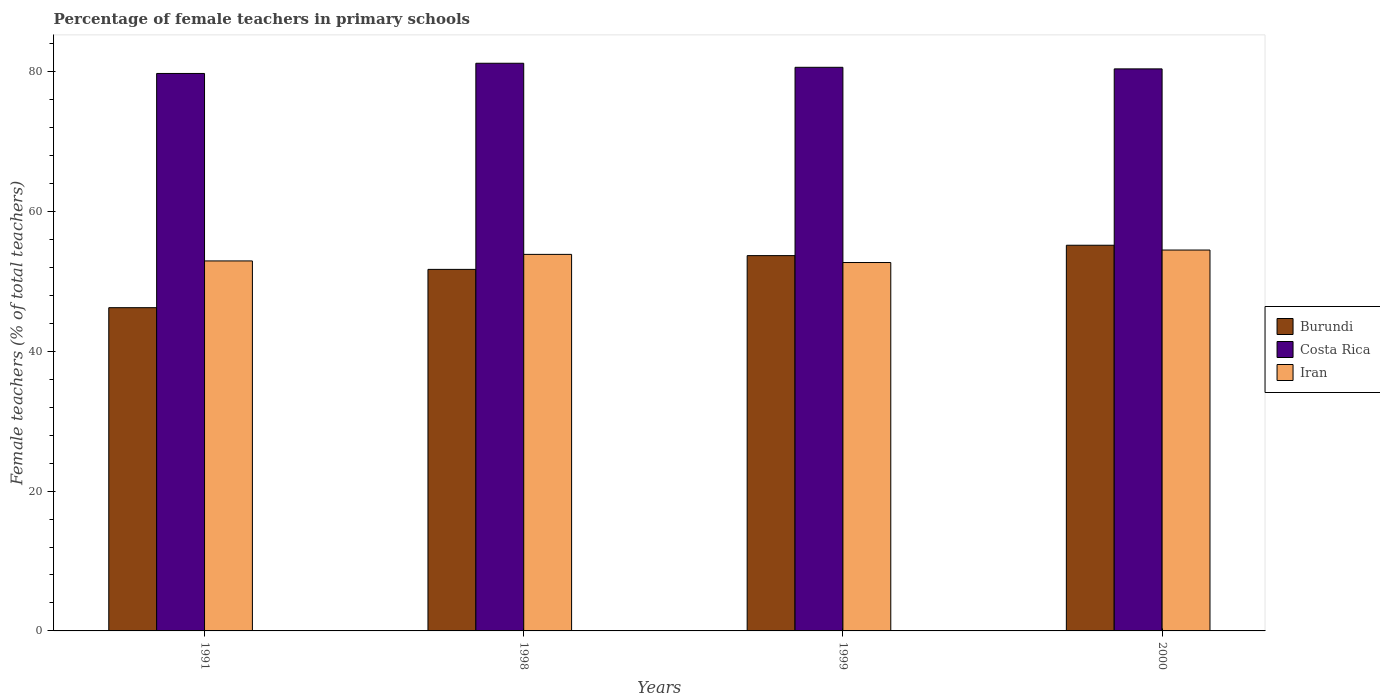How many groups of bars are there?
Provide a short and direct response. 4. Are the number of bars on each tick of the X-axis equal?
Offer a terse response. Yes. How many bars are there on the 3rd tick from the right?
Offer a terse response. 3. What is the label of the 1st group of bars from the left?
Ensure brevity in your answer.  1991. In how many cases, is the number of bars for a given year not equal to the number of legend labels?
Offer a very short reply. 0. What is the percentage of female teachers in Costa Rica in 1998?
Make the answer very short. 81.19. Across all years, what is the maximum percentage of female teachers in Burundi?
Provide a short and direct response. 55.16. Across all years, what is the minimum percentage of female teachers in Burundi?
Give a very brief answer. 46.23. What is the total percentage of female teachers in Burundi in the graph?
Keep it short and to the point. 206.79. What is the difference between the percentage of female teachers in Costa Rica in 1998 and that in 2000?
Keep it short and to the point. 0.8. What is the difference between the percentage of female teachers in Costa Rica in 2000 and the percentage of female teachers in Iran in 1991?
Your answer should be very brief. 27.47. What is the average percentage of female teachers in Iran per year?
Keep it short and to the point. 53.49. In the year 1991, what is the difference between the percentage of female teachers in Iran and percentage of female teachers in Costa Rica?
Make the answer very short. -26.81. In how many years, is the percentage of female teachers in Burundi greater than 60 %?
Ensure brevity in your answer.  0. What is the ratio of the percentage of female teachers in Iran in 1991 to that in 1999?
Make the answer very short. 1. What is the difference between the highest and the second highest percentage of female teachers in Burundi?
Make the answer very short. 1.48. What is the difference between the highest and the lowest percentage of female teachers in Iran?
Give a very brief answer. 1.78. In how many years, is the percentage of female teachers in Iran greater than the average percentage of female teachers in Iran taken over all years?
Provide a succinct answer. 2. What does the 3rd bar from the left in 1999 represents?
Your response must be concise. Iran. What does the 3rd bar from the right in 2000 represents?
Offer a terse response. Burundi. Is it the case that in every year, the sum of the percentage of female teachers in Burundi and percentage of female teachers in Costa Rica is greater than the percentage of female teachers in Iran?
Provide a short and direct response. Yes. Are all the bars in the graph horizontal?
Ensure brevity in your answer.  No. What is the difference between two consecutive major ticks on the Y-axis?
Ensure brevity in your answer.  20. How many legend labels are there?
Make the answer very short. 3. What is the title of the graph?
Your answer should be very brief. Percentage of female teachers in primary schools. Does "Ethiopia" appear as one of the legend labels in the graph?
Offer a very short reply. No. What is the label or title of the Y-axis?
Your answer should be compact. Female teachers (% of total teachers). What is the Female teachers (% of total teachers) of Burundi in 1991?
Your response must be concise. 46.23. What is the Female teachers (% of total teachers) of Costa Rica in 1991?
Your answer should be compact. 79.73. What is the Female teachers (% of total teachers) of Iran in 1991?
Give a very brief answer. 52.92. What is the Female teachers (% of total teachers) of Burundi in 1998?
Your answer should be compact. 51.71. What is the Female teachers (% of total teachers) of Costa Rica in 1998?
Offer a terse response. 81.19. What is the Female teachers (% of total teachers) in Iran in 1998?
Your response must be concise. 53.86. What is the Female teachers (% of total teachers) in Burundi in 1999?
Ensure brevity in your answer.  53.68. What is the Female teachers (% of total teachers) in Costa Rica in 1999?
Provide a short and direct response. 80.62. What is the Female teachers (% of total teachers) of Iran in 1999?
Offer a very short reply. 52.69. What is the Female teachers (% of total teachers) in Burundi in 2000?
Ensure brevity in your answer.  55.16. What is the Female teachers (% of total teachers) in Costa Rica in 2000?
Your answer should be compact. 80.39. What is the Female teachers (% of total teachers) in Iran in 2000?
Make the answer very short. 54.48. Across all years, what is the maximum Female teachers (% of total teachers) of Burundi?
Make the answer very short. 55.16. Across all years, what is the maximum Female teachers (% of total teachers) of Costa Rica?
Provide a short and direct response. 81.19. Across all years, what is the maximum Female teachers (% of total teachers) in Iran?
Your answer should be very brief. 54.48. Across all years, what is the minimum Female teachers (% of total teachers) of Burundi?
Give a very brief answer. 46.23. Across all years, what is the minimum Female teachers (% of total teachers) of Costa Rica?
Your answer should be compact. 79.73. Across all years, what is the minimum Female teachers (% of total teachers) in Iran?
Your answer should be compact. 52.69. What is the total Female teachers (% of total teachers) in Burundi in the graph?
Keep it short and to the point. 206.79. What is the total Female teachers (% of total teachers) of Costa Rica in the graph?
Make the answer very short. 321.93. What is the total Female teachers (% of total teachers) in Iran in the graph?
Offer a very short reply. 213.95. What is the difference between the Female teachers (% of total teachers) of Burundi in 1991 and that in 1998?
Your response must be concise. -5.48. What is the difference between the Female teachers (% of total teachers) of Costa Rica in 1991 and that in 1998?
Give a very brief answer. -1.46. What is the difference between the Female teachers (% of total teachers) in Iran in 1991 and that in 1998?
Provide a succinct answer. -0.94. What is the difference between the Female teachers (% of total teachers) of Burundi in 1991 and that in 1999?
Your response must be concise. -7.45. What is the difference between the Female teachers (% of total teachers) in Costa Rica in 1991 and that in 1999?
Your answer should be very brief. -0.88. What is the difference between the Female teachers (% of total teachers) in Iran in 1991 and that in 1999?
Provide a short and direct response. 0.23. What is the difference between the Female teachers (% of total teachers) of Burundi in 1991 and that in 2000?
Make the answer very short. -8.93. What is the difference between the Female teachers (% of total teachers) of Costa Rica in 1991 and that in 2000?
Provide a succinct answer. -0.66. What is the difference between the Female teachers (% of total teachers) of Iran in 1991 and that in 2000?
Give a very brief answer. -1.56. What is the difference between the Female teachers (% of total teachers) in Burundi in 1998 and that in 1999?
Keep it short and to the point. -1.97. What is the difference between the Female teachers (% of total teachers) in Costa Rica in 1998 and that in 1999?
Provide a short and direct response. 0.58. What is the difference between the Female teachers (% of total teachers) of Iran in 1998 and that in 1999?
Your answer should be very brief. 1.16. What is the difference between the Female teachers (% of total teachers) in Burundi in 1998 and that in 2000?
Your answer should be compact. -3.45. What is the difference between the Female teachers (% of total teachers) in Costa Rica in 1998 and that in 2000?
Give a very brief answer. 0.8. What is the difference between the Female teachers (% of total teachers) in Iran in 1998 and that in 2000?
Give a very brief answer. -0.62. What is the difference between the Female teachers (% of total teachers) of Burundi in 1999 and that in 2000?
Offer a very short reply. -1.48. What is the difference between the Female teachers (% of total teachers) of Costa Rica in 1999 and that in 2000?
Offer a terse response. 0.23. What is the difference between the Female teachers (% of total teachers) of Iran in 1999 and that in 2000?
Provide a short and direct response. -1.78. What is the difference between the Female teachers (% of total teachers) of Burundi in 1991 and the Female teachers (% of total teachers) of Costa Rica in 1998?
Offer a very short reply. -34.96. What is the difference between the Female teachers (% of total teachers) of Burundi in 1991 and the Female teachers (% of total teachers) of Iran in 1998?
Your response must be concise. -7.62. What is the difference between the Female teachers (% of total teachers) in Costa Rica in 1991 and the Female teachers (% of total teachers) in Iran in 1998?
Offer a very short reply. 25.88. What is the difference between the Female teachers (% of total teachers) in Burundi in 1991 and the Female teachers (% of total teachers) in Costa Rica in 1999?
Your answer should be very brief. -34.38. What is the difference between the Female teachers (% of total teachers) of Burundi in 1991 and the Female teachers (% of total teachers) of Iran in 1999?
Give a very brief answer. -6.46. What is the difference between the Female teachers (% of total teachers) in Costa Rica in 1991 and the Female teachers (% of total teachers) in Iran in 1999?
Your answer should be very brief. 27.04. What is the difference between the Female teachers (% of total teachers) in Burundi in 1991 and the Female teachers (% of total teachers) in Costa Rica in 2000?
Your answer should be compact. -34.16. What is the difference between the Female teachers (% of total teachers) of Burundi in 1991 and the Female teachers (% of total teachers) of Iran in 2000?
Provide a short and direct response. -8.25. What is the difference between the Female teachers (% of total teachers) in Costa Rica in 1991 and the Female teachers (% of total teachers) in Iran in 2000?
Give a very brief answer. 25.26. What is the difference between the Female teachers (% of total teachers) in Burundi in 1998 and the Female teachers (% of total teachers) in Costa Rica in 1999?
Give a very brief answer. -28.9. What is the difference between the Female teachers (% of total teachers) in Burundi in 1998 and the Female teachers (% of total teachers) in Iran in 1999?
Your answer should be very brief. -0.98. What is the difference between the Female teachers (% of total teachers) in Costa Rica in 1998 and the Female teachers (% of total teachers) in Iran in 1999?
Your answer should be compact. 28.5. What is the difference between the Female teachers (% of total teachers) in Burundi in 1998 and the Female teachers (% of total teachers) in Costa Rica in 2000?
Ensure brevity in your answer.  -28.68. What is the difference between the Female teachers (% of total teachers) in Burundi in 1998 and the Female teachers (% of total teachers) in Iran in 2000?
Ensure brevity in your answer.  -2.77. What is the difference between the Female teachers (% of total teachers) in Costa Rica in 1998 and the Female teachers (% of total teachers) in Iran in 2000?
Give a very brief answer. 26.72. What is the difference between the Female teachers (% of total teachers) in Burundi in 1999 and the Female teachers (% of total teachers) in Costa Rica in 2000?
Make the answer very short. -26.71. What is the difference between the Female teachers (% of total teachers) in Burundi in 1999 and the Female teachers (% of total teachers) in Iran in 2000?
Ensure brevity in your answer.  -0.8. What is the difference between the Female teachers (% of total teachers) in Costa Rica in 1999 and the Female teachers (% of total teachers) in Iran in 2000?
Provide a short and direct response. 26.14. What is the average Female teachers (% of total teachers) of Burundi per year?
Offer a terse response. 51.7. What is the average Female teachers (% of total teachers) in Costa Rica per year?
Make the answer very short. 80.48. What is the average Female teachers (% of total teachers) in Iran per year?
Your answer should be very brief. 53.49. In the year 1991, what is the difference between the Female teachers (% of total teachers) in Burundi and Female teachers (% of total teachers) in Costa Rica?
Make the answer very short. -33.5. In the year 1991, what is the difference between the Female teachers (% of total teachers) in Burundi and Female teachers (% of total teachers) in Iran?
Provide a short and direct response. -6.69. In the year 1991, what is the difference between the Female teachers (% of total teachers) in Costa Rica and Female teachers (% of total teachers) in Iran?
Offer a terse response. 26.81. In the year 1998, what is the difference between the Female teachers (% of total teachers) in Burundi and Female teachers (% of total teachers) in Costa Rica?
Ensure brevity in your answer.  -29.48. In the year 1998, what is the difference between the Female teachers (% of total teachers) in Burundi and Female teachers (% of total teachers) in Iran?
Provide a short and direct response. -2.15. In the year 1998, what is the difference between the Female teachers (% of total teachers) of Costa Rica and Female teachers (% of total teachers) of Iran?
Keep it short and to the point. 27.34. In the year 1999, what is the difference between the Female teachers (% of total teachers) of Burundi and Female teachers (% of total teachers) of Costa Rica?
Your answer should be very brief. -26.94. In the year 1999, what is the difference between the Female teachers (% of total teachers) in Burundi and Female teachers (% of total teachers) in Iran?
Your answer should be compact. 0.99. In the year 1999, what is the difference between the Female teachers (% of total teachers) of Costa Rica and Female teachers (% of total teachers) of Iran?
Your response must be concise. 27.92. In the year 2000, what is the difference between the Female teachers (% of total teachers) of Burundi and Female teachers (% of total teachers) of Costa Rica?
Provide a succinct answer. -25.23. In the year 2000, what is the difference between the Female teachers (% of total teachers) of Burundi and Female teachers (% of total teachers) of Iran?
Offer a terse response. 0.69. In the year 2000, what is the difference between the Female teachers (% of total teachers) in Costa Rica and Female teachers (% of total teachers) in Iran?
Keep it short and to the point. 25.91. What is the ratio of the Female teachers (% of total teachers) in Burundi in 1991 to that in 1998?
Offer a terse response. 0.89. What is the ratio of the Female teachers (% of total teachers) in Costa Rica in 1991 to that in 1998?
Your answer should be compact. 0.98. What is the ratio of the Female teachers (% of total teachers) in Iran in 1991 to that in 1998?
Ensure brevity in your answer.  0.98. What is the ratio of the Female teachers (% of total teachers) in Burundi in 1991 to that in 1999?
Keep it short and to the point. 0.86. What is the ratio of the Female teachers (% of total teachers) in Costa Rica in 1991 to that in 1999?
Give a very brief answer. 0.99. What is the ratio of the Female teachers (% of total teachers) in Burundi in 1991 to that in 2000?
Your answer should be very brief. 0.84. What is the ratio of the Female teachers (% of total teachers) of Costa Rica in 1991 to that in 2000?
Offer a terse response. 0.99. What is the ratio of the Female teachers (% of total teachers) in Iran in 1991 to that in 2000?
Give a very brief answer. 0.97. What is the ratio of the Female teachers (% of total teachers) of Burundi in 1998 to that in 1999?
Make the answer very short. 0.96. What is the ratio of the Female teachers (% of total teachers) in Iran in 1998 to that in 1999?
Provide a short and direct response. 1.02. What is the ratio of the Female teachers (% of total teachers) in Burundi in 1998 to that in 2000?
Your answer should be compact. 0.94. What is the ratio of the Female teachers (% of total teachers) in Burundi in 1999 to that in 2000?
Your answer should be compact. 0.97. What is the ratio of the Female teachers (% of total teachers) in Costa Rica in 1999 to that in 2000?
Your answer should be compact. 1. What is the ratio of the Female teachers (% of total teachers) in Iran in 1999 to that in 2000?
Offer a very short reply. 0.97. What is the difference between the highest and the second highest Female teachers (% of total teachers) in Burundi?
Your response must be concise. 1.48. What is the difference between the highest and the second highest Female teachers (% of total teachers) of Costa Rica?
Keep it short and to the point. 0.58. What is the difference between the highest and the second highest Female teachers (% of total teachers) in Iran?
Make the answer very short. 0.62. What is the difference between the highest and the lowest Female teachers (% of total teachers) of Burundi?
Ensure brevity in your answer.  8.93. What is the difference between the highest and the lowest Female teachers (% of total teachers) in Costa Rica?
Keep it short and to the point. 1.46. What is the difference between the highest and the lowest Female teachers (% of total teachers) in Iran?
Ensure brevity in your answer.  1.78. 